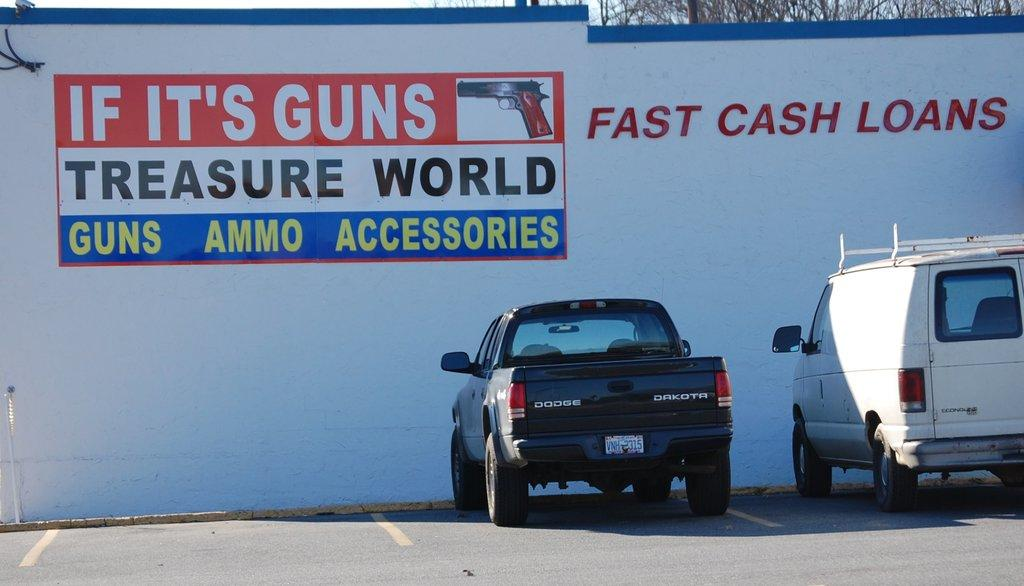<image>
Relay a brief, clear account of the picture shown. A building that is titled Fast Cash Loans. 